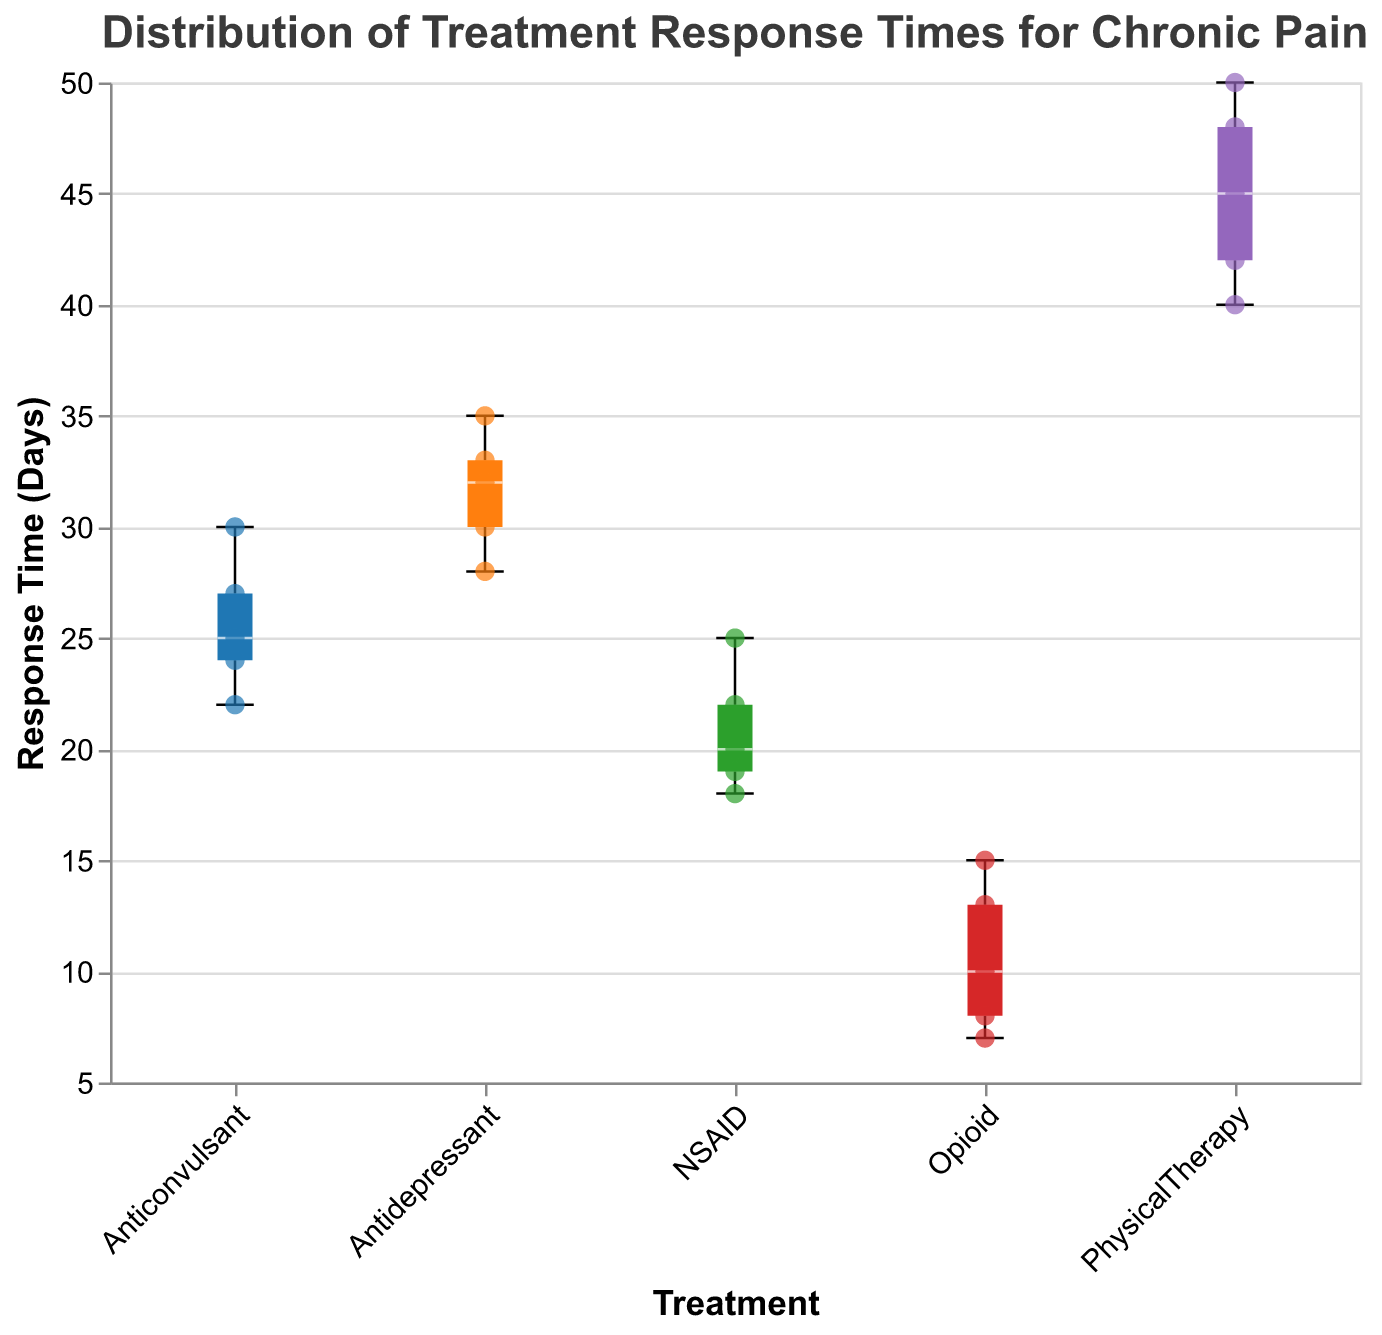What is the title of the figure? The title is at the top of the figure, written in larger and bold font. In this case, the title reads, "Distribution of Treatment Response Times for Chronic Pain."
Answer: Distribution of Treatment Response Times for Chronic Pain Which treatment category has the longest median response time? In box plots, the median is represented by the horizontal line inside the box. The "Physical Therapy" category has the longest median response time as its median line is higher than the other categories.
Answer: Physical Therapy How many data points are there for the Opioid treatment category? Each scatter point on the box plot represents a data point. For the "Opioid" category, there are five scatter points.
Answer: 5 Which treatment category has the smallest range of response times? The range can be observed from the minimum to maximum whiskers in the box plot. The "Opioid" category has the smallest range as its whiskers are closest together.
Answer: Opioid What is the interquartile range (IQR) for the Anticonvulsant treatment category? The IQR in box plots is represented by the box itself and includes the middle 50% of the data. Estimating from the visual representation, the lower quartile (Q1) is around 23 and the upper quartile (Q3) is around 28. So, IQR = Q3 - Q1 = 28 - 23 = 5.
Answer: 5 Which two treatment categories have overlapping interquartile ranges? Interquartile range (IQR) is the range covered by the box. "NSAID" and "Anticonvulsant" have overlapping boxes, thus overlapping IQRs.
Answer: NSAID and Anticonvulsant What is the median response time for the Antidepressant treatment category? The median for the Antidepressant category is the horizontal line inside its box, which is visually closest to 32.
Answer: 32 Which treatment shows the greatest variability in response times? Variability in response times can be deciphered by the length of the whiskers. "Physical Therapy" has the greatest whisker length, indicating maximum variability.
Answer: Physical Therapy Is there any treatment category where all response times are greater than 15 days? To determine this, we need to check if the minimum whisker (lowest point) for any category is greater than 15 days. "Physical Therapy" fits this criterion as all its points are above 15.
Answer: Physical Therapy 